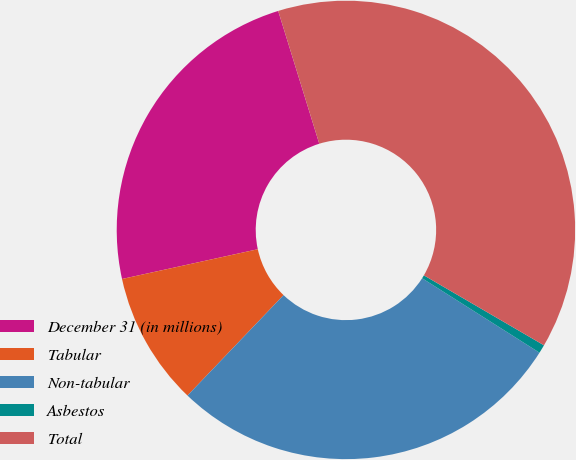<chart> <loc_0><loc_0><loc_500><loc_500><pie_chart><fcel>December 31 (in millions)<fcel>Tabular<fcel>Non-tabular<fcel>Asbestos<fcel>Total<nl><fcel>23.66%<fcel>9.42%<fcel>28.15%<fcel>0.6%<fcel>38.17%<nl></chart> 